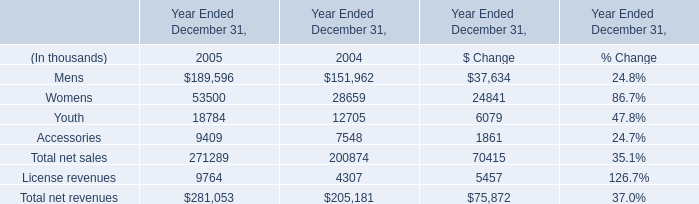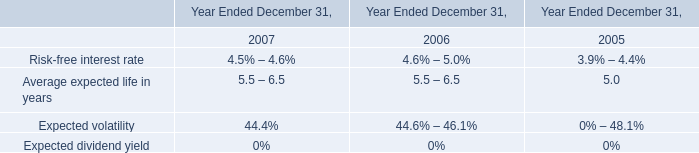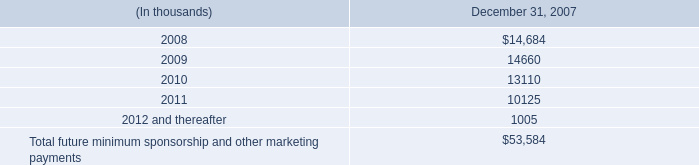what was the percent of growth in gross profit from 2004 to 2005\\n 
Computations: (40.5 / 95.4)
Answer: 0.42453. 